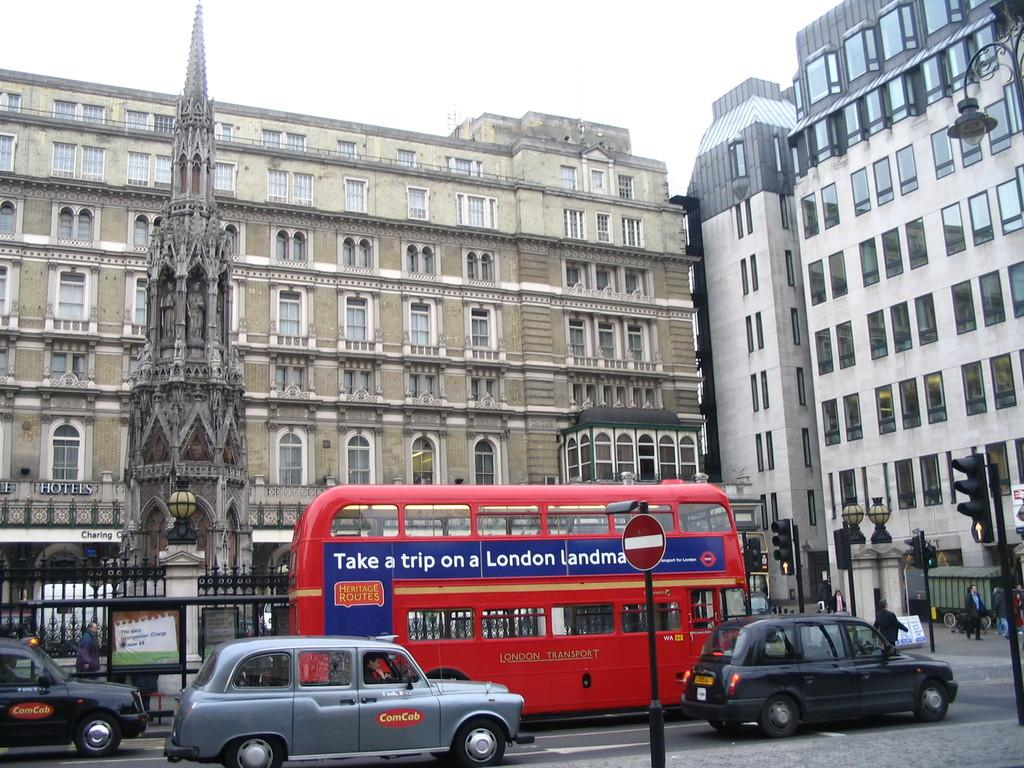Provide a one-sentence caption for the provided image. british street with silver comcab and red double decker bus advising to take a trip on a london landmark. 